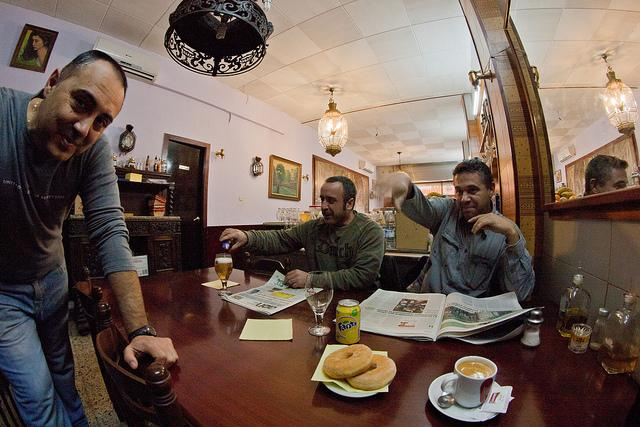How does the person in the image tell time?

Choices:
A) wrist watch
B) wall clock
C) phone
D) microwave wrist watch 